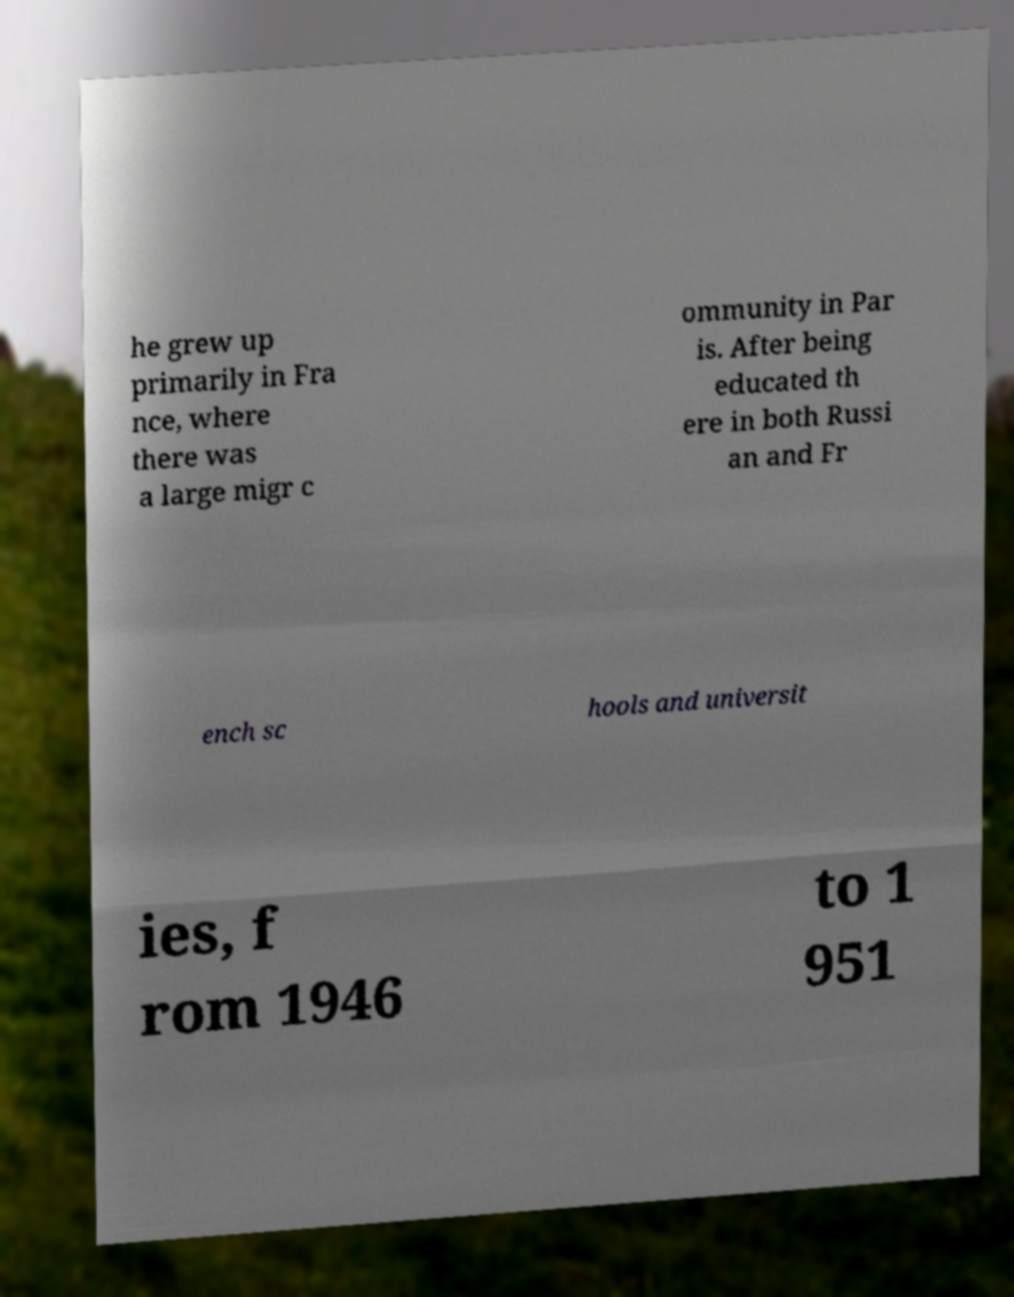For documentation purposes, I need the text within this image transcribed. Could you provide that? he grew up primarily in Fra nce, where there was a large migr c ommunity in Par is. After being educated th ere in both Russi an and Fr ench sc hools and universit ies, f rom 1946 to 1 951 